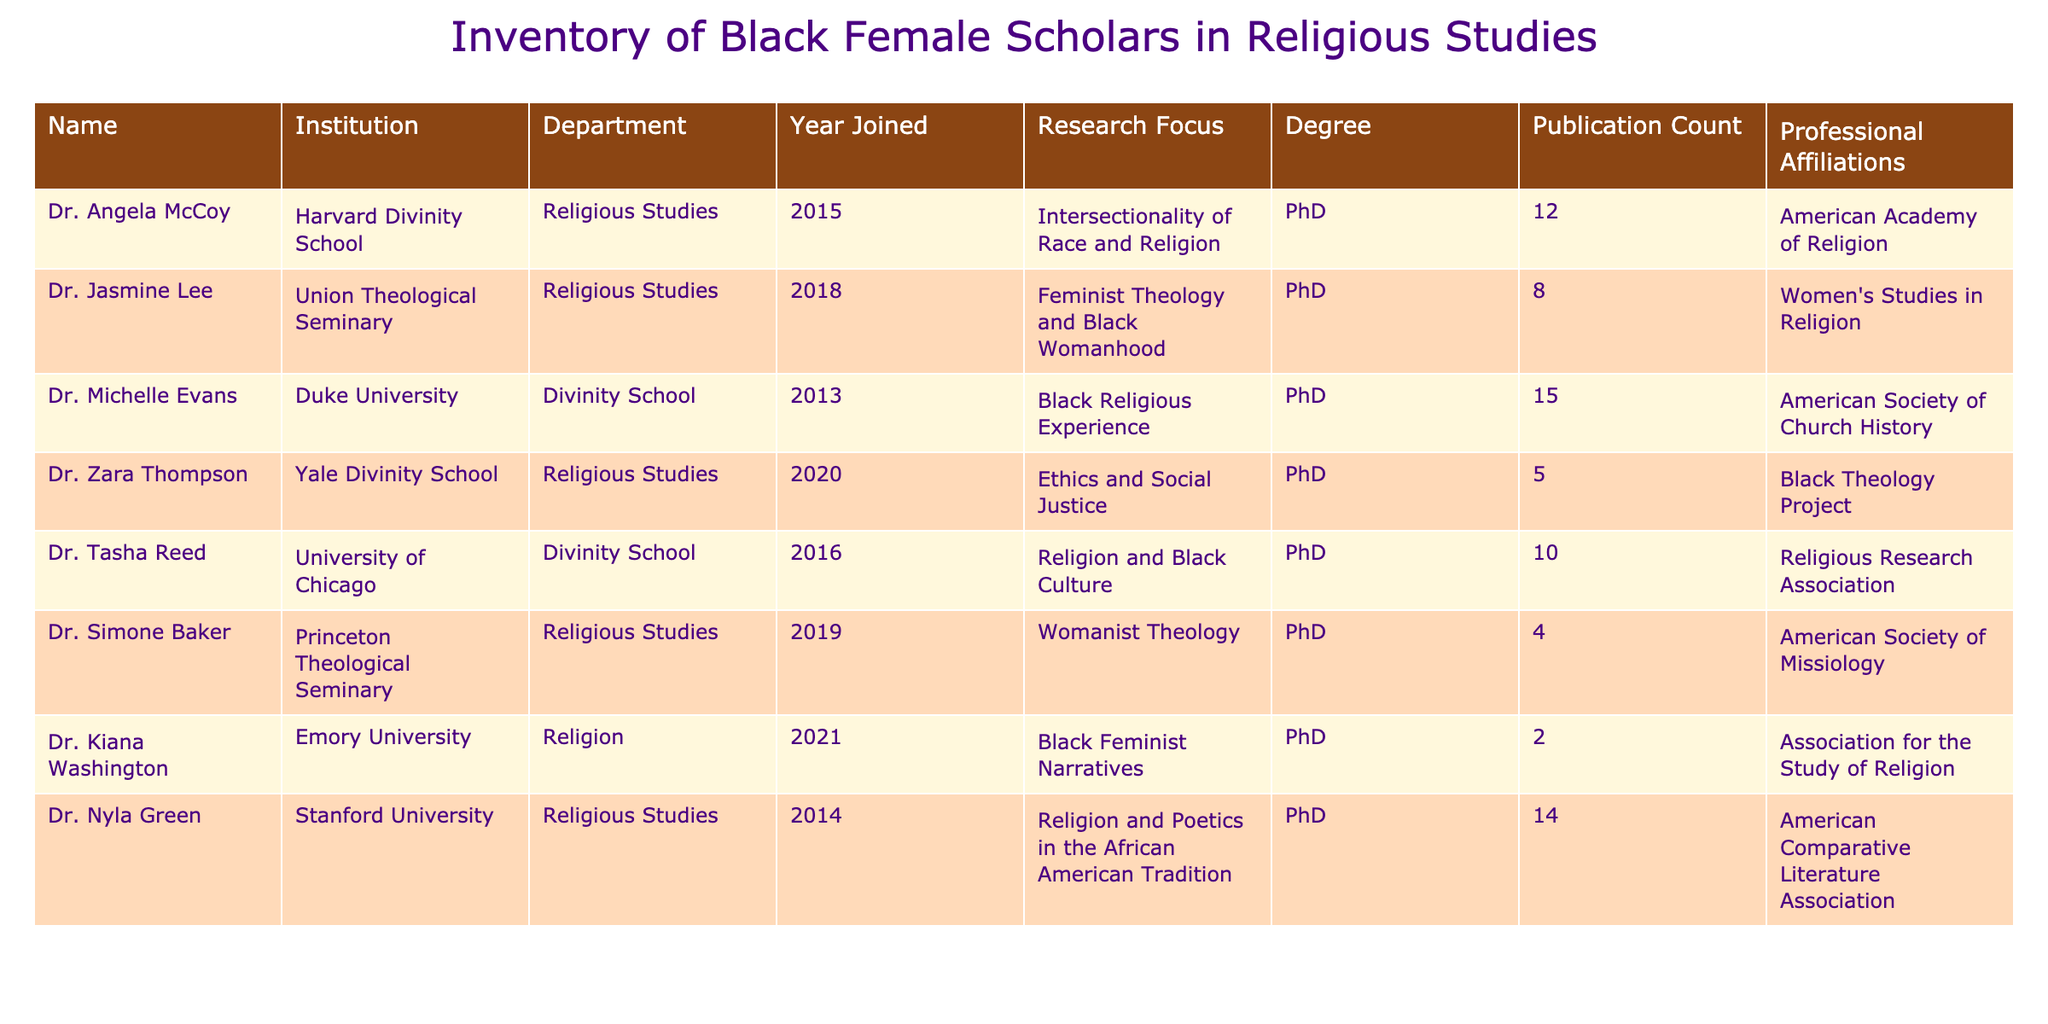What is the name of the scholar with the highest publication count? By reviewing the "Publication Count" column, we see that Dr. Michelle Evans has the highest publication count, which is 15.
Answer: Dr. Michelle Evans How many scholars have joined their respective institutions since 2016? The years of joining for scholars after 2016 are: Dr. Tasha Reed (2016), Dr. Angela McCoy (2015), Dr. Jasmine Lee (2018), Dr. Zara Thompson (2020), Dr. Simone Baker (2019), Dr. Kiana Washington (2021). There are four scholars who joined since 2016: Dr. Jasmine Lee, Dr. Zara Thompson, Dr. Simone Baker, and Dr. Kiana Washington.
Answer: 4 Is Dr. Kiana Washington affiliated with the American Academy of Religion? Checking the "Professional Affiliations" column reveals that Dr. Kiana Washington is affiliated with the Association for the Study of Religion, not the American Academy of Religion.
Answer: No What is the median publication count among the scholars listed? To find the median, we first list the publication counts: 12, 8, 15, 5, 10, 4, 2, 14. Arranging these in ascending order gives: 2, 4, 5, 8, 10, 12, 14, 15. Since there are 8 values, the median is the average of the 4th and 5th values (8 + 10) / 2 = 9.
Answer: 9 Which institution has the scholar with a research focus on "Black Feminist Narratives"? By looking at the "Research Focus" column, I find that Dr. Kiana Washington at Emory University has a focus on "Black Feminist Narratives."
Answer: Emory University How many scholars focus on womanist theology and feminist theology? Dr. Jasmine Lee specializes in Feminist Theology and Black Womanhood, while Dr. Simone Baker focuses on Womanist Theology. Therefore, there are two scholars focusing on these fields.
Answer: 2 Are there any scholars affiliated with the Black Theology Project? Reviewing the "Professional Affiliations" column shows that Dr. Zara Thompson is affiliated with the Black Theology Project, indicating at least one scholar is associated with it.
Answer: Yes What are the research focuses of scholars who joined their institutions in 2019 or later? The scholars who joined in 2019 or later are Dr. Jasmine Lee (2018), Dr. Zara Thompson (2020), Dr. Simone Baker (2019), and Dr. Kiana Washington (2021). Their research focuses are: Dr. Jasmine Lee - Feminist Theology and Black Womanhood, Dr. Zara Thompson - Ethics and Social Justice, Dr. Simone Baker - Womanist Theology, and Dr. Kiana Washington - Black Feminist Narratives.
Answer: 4 (Feminist Theology and Black Womanhood, Ethics and Social Justice, Womanist Theology, Black Feminist Narratives) 